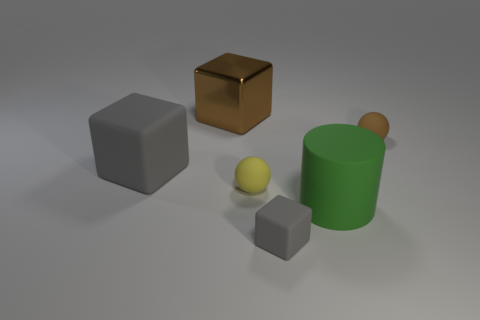What material is the small ball that is behind the matte object that is left of the brown metal thing made of?
Keep it short and to the point. Rubber. How many objects are either tiny purple shiny things or objects behind the big gray block?
Offer a terse response. 2. What size is the brown sphere that is made of the same material as the yellow thing?
Ensure brevity in your answer.  Small. What number of red things are either small blocks or balls?
Keep it short and to the point. 0. There is a big object that is the same color as the tiny cube; what is its shape?
Give a very brief answer. Cube. Is there any other thing that has the same material as the big brown thing?
Offer a terse response. No. Do the tiny object in front of the large matte cylinder and the brown thing left of the green matte thing have the same shape?
Your response must be concise. Yes. What number of big blue balls are there?
Keep it short and to the point. 0. The green object that is made of the same material as the small gray cube is what shape?
Give a very brief answer. Cylinder. Is there anything else of the same color as the large rubber cylinder?
Provide a succinct answer. No. 